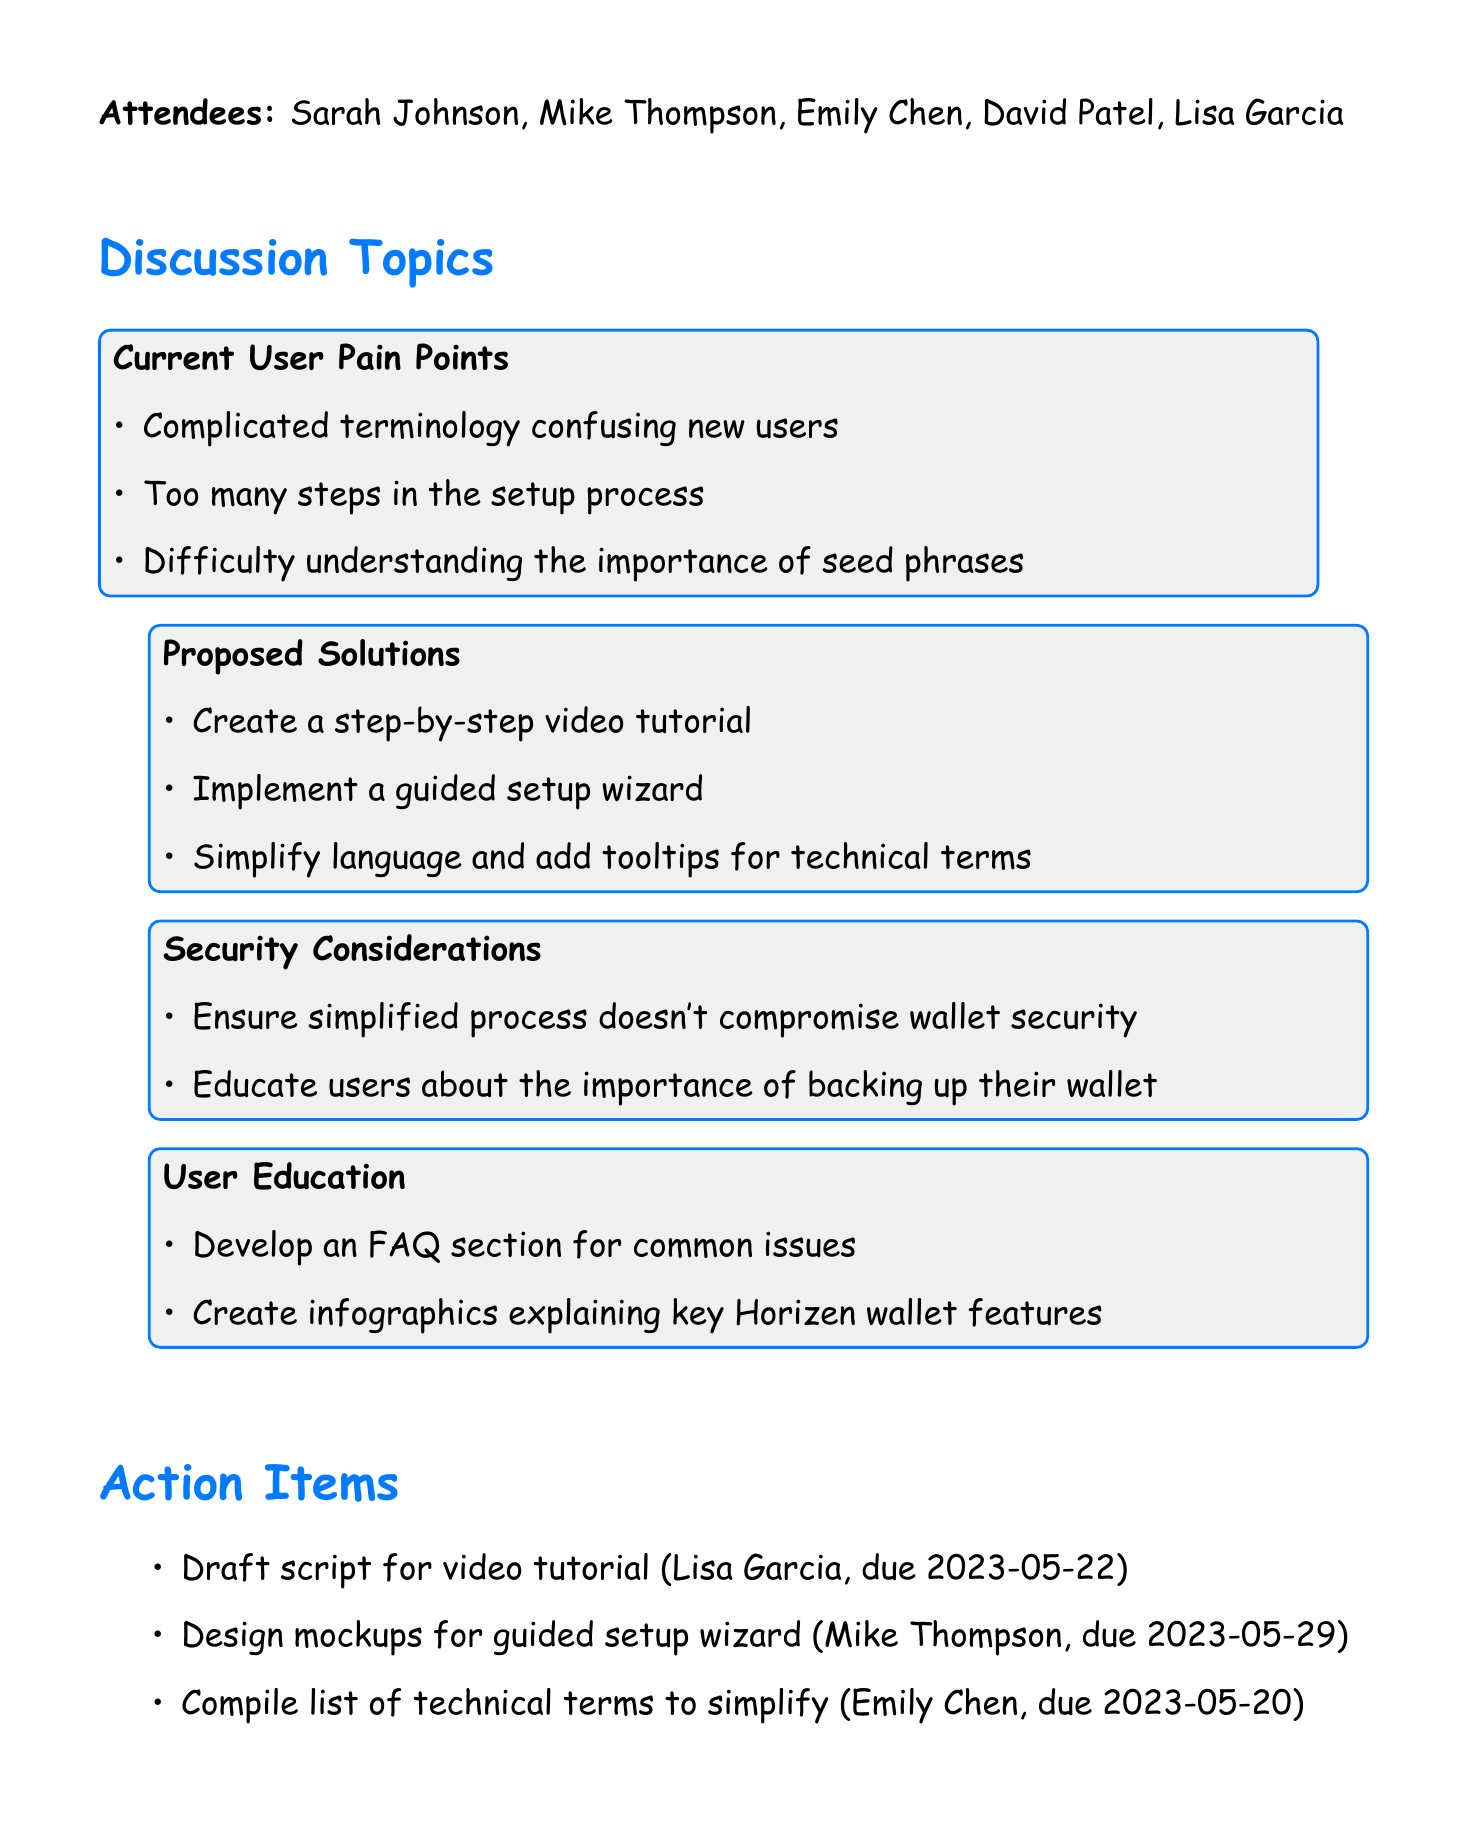What was the meeting date? The meeting date is specified in the document.
Answer: 2023-05-15 Who is responsible for drafting the script for the video tutorial? The action items outline who is responsible for each task.
Answer: Lisa Garcia What are the proposed solutions to simplify the wallet setup? The document lists various proposed solutions under their respective discussion topic.
Answer: Create a step-by-step video tutorial, Implement a guided setup wizard, Simplify language and add tooltips for technical terms How many attendees were at the meeting? The number of attendees is mentioned in the attendees list.
Answer: Five What is one of the current user pain points discussed? Current user pain points are outlined in the discussion topics section.
Answer: Complicated terminology confusing new users When is the next meeting scheduled? The next meeting date is mentioned at the top of the document.
Answer: 2023-05-29 Who will design the mockups for the guided setup wizard? The action items specify who is tasked with designing the mockups.
Answer: Mike Thompson What is an educational task mentioned in the user education section? The user education section lists specific educational tasks to be developed.
Answer: Develop an FAQ section for common issues What is the deadline for compiling the list of technical terms? The deadlines for each action item are specified in the action items section.
Answer: 2023-05-20 